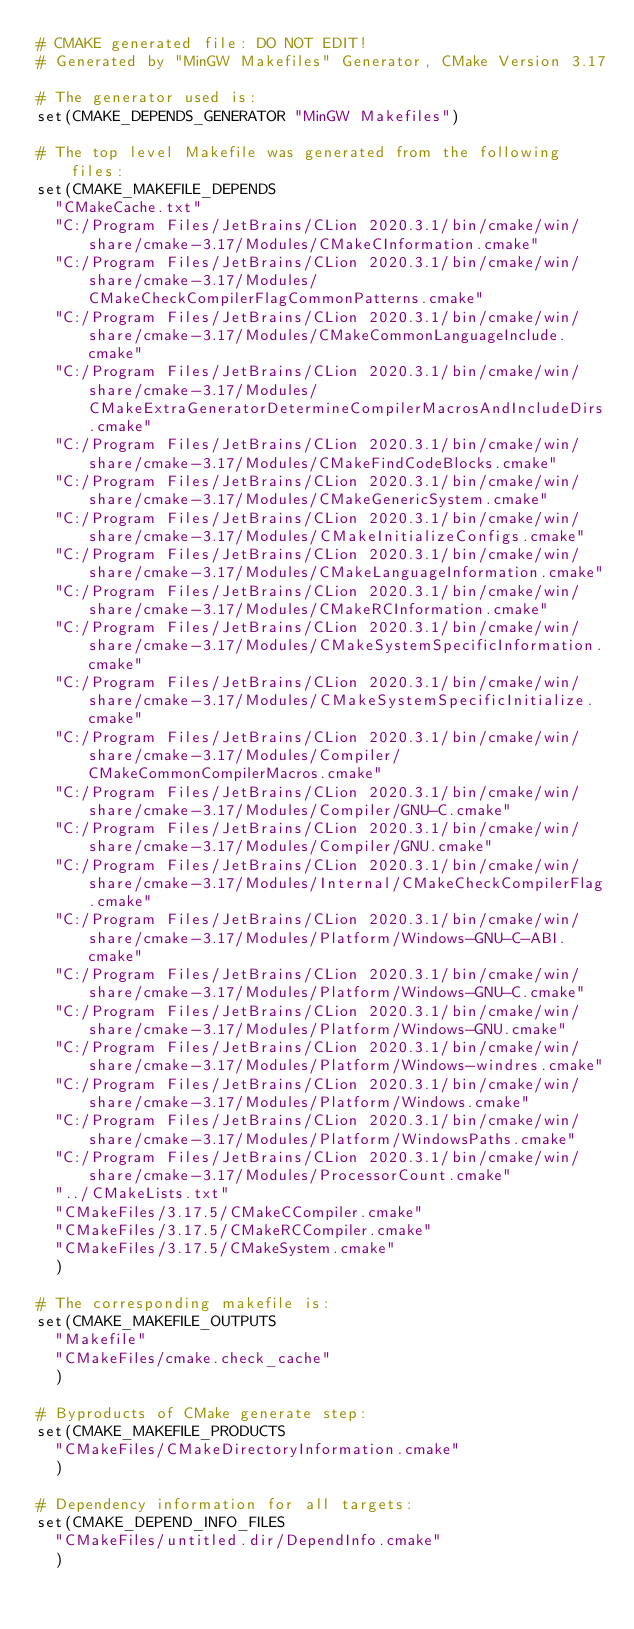Convert code to text. <code><loc_0><loc_0><loc_500><loc_500><_CMake_># CMAKE generated file: DO NOT EDIT!
# Generated by "MinGW Makefiles" Generator, CMake Version 3.17

# The generator used is:
set(CMAKE_DEPENDS_GENERATOR "MinGW Makefiles")

# The top level Makefile was generated from the following files:
set(CMAKE_MAKEFILE_DEPENDS
  "CMakeCache.txt"
  "C:/Program Files/JetBrains/CLion 2020.3.1/bin/cmake/win/share/cmake-3.17/Modules/CMakeCInformation.cmake"
  "C:/Program Files/JetBrains/CLion 2020.3.1/bin/cmake/win/share/cmake-3.17/Modules/CMakeCheckCompilerFlagCommonPatterns.cmake"
  "C:/Program Files/JetBrains/CLion 2020.3.1/bin/cmake/win/share/cmake-3.17/Modules/CMakeCommonLanguageInclude.cmake"
  "C:/Program Files/JetBrains/CLion 2020.3.1/bin/cmake/win/share/cmake-3.17/Modules/CMakeExtraGeneratorDetermineCompilerMacrosAndIncludeDirs.cmake"
  "C:/Program Files/JetBrains/CLion 2020.3.1/bin/cmake/win/share/cmake-3.17/Modules/CMakeFindCodeBlocks.cmake"
  "C:/Program Files/JetBrains/CLion 2020.3.1/bin/cmake/win/share/cmake-3.17/Modules/CMakeGenericSystem.cmake"
  "C:/Program Files/JetBrains/CLion 2020.3.1/bin/cmake/win/share/cmake-3.17/Modules/CMakeInitializeConfigs.cmake"
  "C:/Program Files/JetBrains/CLion 2020.3.1/bin/cmake/win/share/cmake-3.17/Modules/CMakeLanguageInformation.cmake"
  "C:/Program Files/JetBrains/CLion 2020.3.1/bin/cmake/win/share/cmake-3.17/Modules/CMakeRCInformation.cmake"
  "C:/Program Files/JetBrains/CLion 2020.3.1/bin/cmake/win/share/cmake-3.17/Modules/CMakeSystemSpecificInformation.cmake"
  "C:/Program Files/JetBrains/CLion 2020.3.1/bin/cmake/win/share/cmake-3.17/Modules/CMakeSystemSpecificInitialize.cmake"
  "C:/Program Files/JetBrains/CLion 2020.3.1/bin/cmake/win/share/cmake-3.17/Modules/Compiler/CMakeCommonCompilerMacros.cmake"
  "C:/Program Files/JetBrains/CLion 2020.3.1/bin/cmake/win/share/cmake-3.17/Modules/Compiler/GNU-C.cmake"
  "C:/Program Files/JetBrains/CLion 2020.3.1/bin/cmake/win/share/cmake-3.17/Modules/Compiler/GNU.cmake"
  "C:/Program Files/JetBrains/CLion 2020.3.1/bin/cmake/win/share/cmake-3.17/Modules/Internal/CMakeCheckCompilerFlag.cmake"
  "C:/Program Files/JetBrains/CLion 2020.3.1/bin/cmake/win/share/cmake-3.17/Modules/Platform/Windows-GNU-C-ABI.cmake"
  "C:/Program Files/JetBrains/CLion 2020.3.1/bin/cmake/win/share/cmake-3.17/Modules/Platform/Windows-GNU-C.cmake"
  "C:/Program Files/JetBrains/CLion 2020.3.1/bin/cmake/win/share/cmake-3.17/Modules/Platform/Windows-GNU.cmake"
  "C:/Program Files/JetBrains/CLion 2020.3.1/bin/cmake/win/share/cmake-3.17/Modules/Platform/Windows-windres.cmake"
  "C:/Program Files/JetBrains/CLion 2020.3.1/bin/cmake/win/share/cmake-3.17/Modules/Platform/Windows.cmake"
  "C:/Program Files/JetBrains/CLion 2020.3.1/bin/cmake/win/share/cmake-3.17/Modules/Platform/WindowsPaths.cmake"
  "C:/Program Files/JetBrains/CLion 2020.3.1/bin/cmake/win/share/cmake-3.17/Modules/ProcessorCount.cmake"
  "../CMakeLists.txt"
  "CMakeFiles/3.17.5/CMakeCCompiler.cmake"
  "CMakeFiles/3.17.5/CMakeRCCompiler.cmake"
  "CMakeFiles/3.17.5/CMakeSystem.cmake"
  )

# The corresponding makefile is:
set(CMAKE_MAKEFILE_OUTPUTS
  "Makefile"
  "CMakeFiles/cmake.check_cache"
  )

# Byproducts of CMake generate step:
set(CMAKE_MAKEFILE_PRODUCTS
  "CMakeFiles/CMakeDirectoryInformation.cmake"
  )

# Dependency information for all targets:
set(CMAKE_DEPEND_INFO_FILES
  "CMakeFiles/untitled.dir/DependInfo.cmake"
  )
</code> 